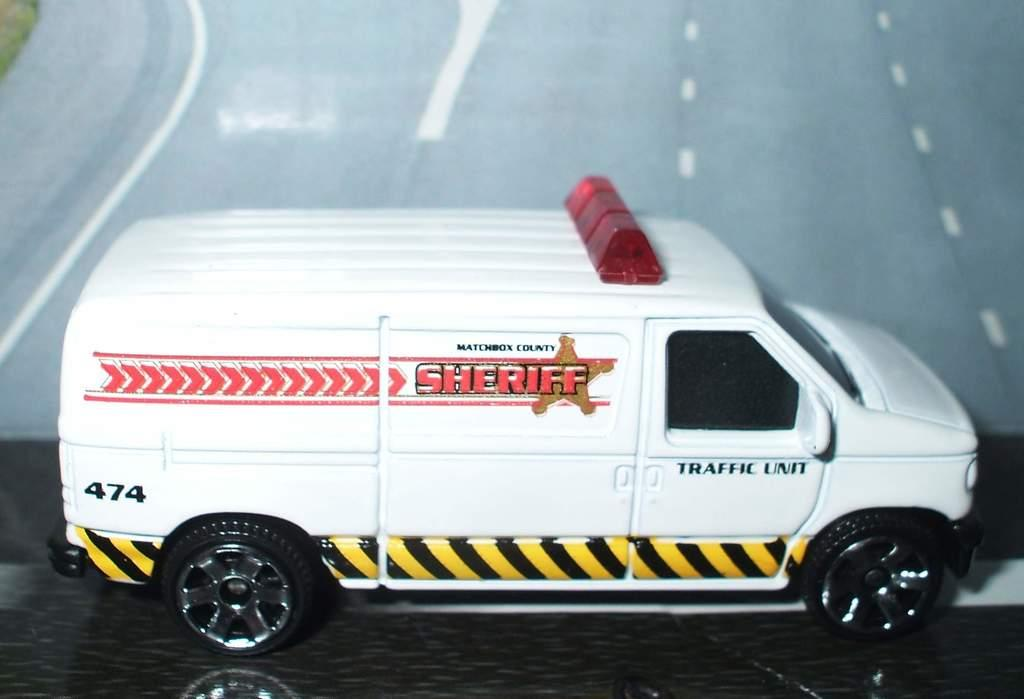Provide a one-sentence caption for the provided image. A small toy version of a sheriff's white van with a street backdrop. 